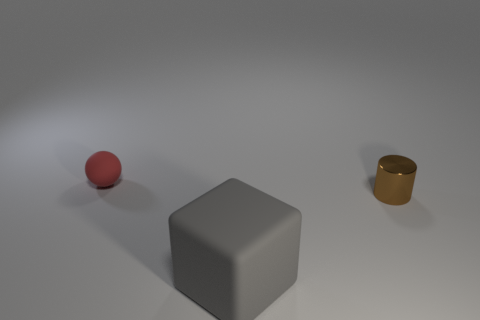Do the brown cylinder behind the gray rubber block and the big matte block have the same size?
Ensure brevity in your answer.  No. What shape is the gray matte thing?
Ensure brevity in your answer.  Cube. Do the object right of the gray matte cube and the big gray block have the same material?
Ensure brevity in your answer.  No. Are there any other things of the same color as the metal object?
Give a very brief answer. No. Is the shape of the tiny thing to the left of the big rubber cube the same as the thing in front of the brown metallic object?
Provide a succinct answer. No. Are there any large brown balls made of the same material as the gray block?
Make the answer very short. No. What number of yellow objects are either metallic cylinders or big matte cubes?
Your answer should be compact. 0. What is the size of the object that is right of the tiny rubber object and behind the large rubber block?
Your response must be concise. Small. Are there more tiny brown metal objects that are on the left side of the brown thing than red rubber balls?
Provide a short and direct response. No. What number of balls are either big matte things or red rubber things?
Your response must be concise. 1. 